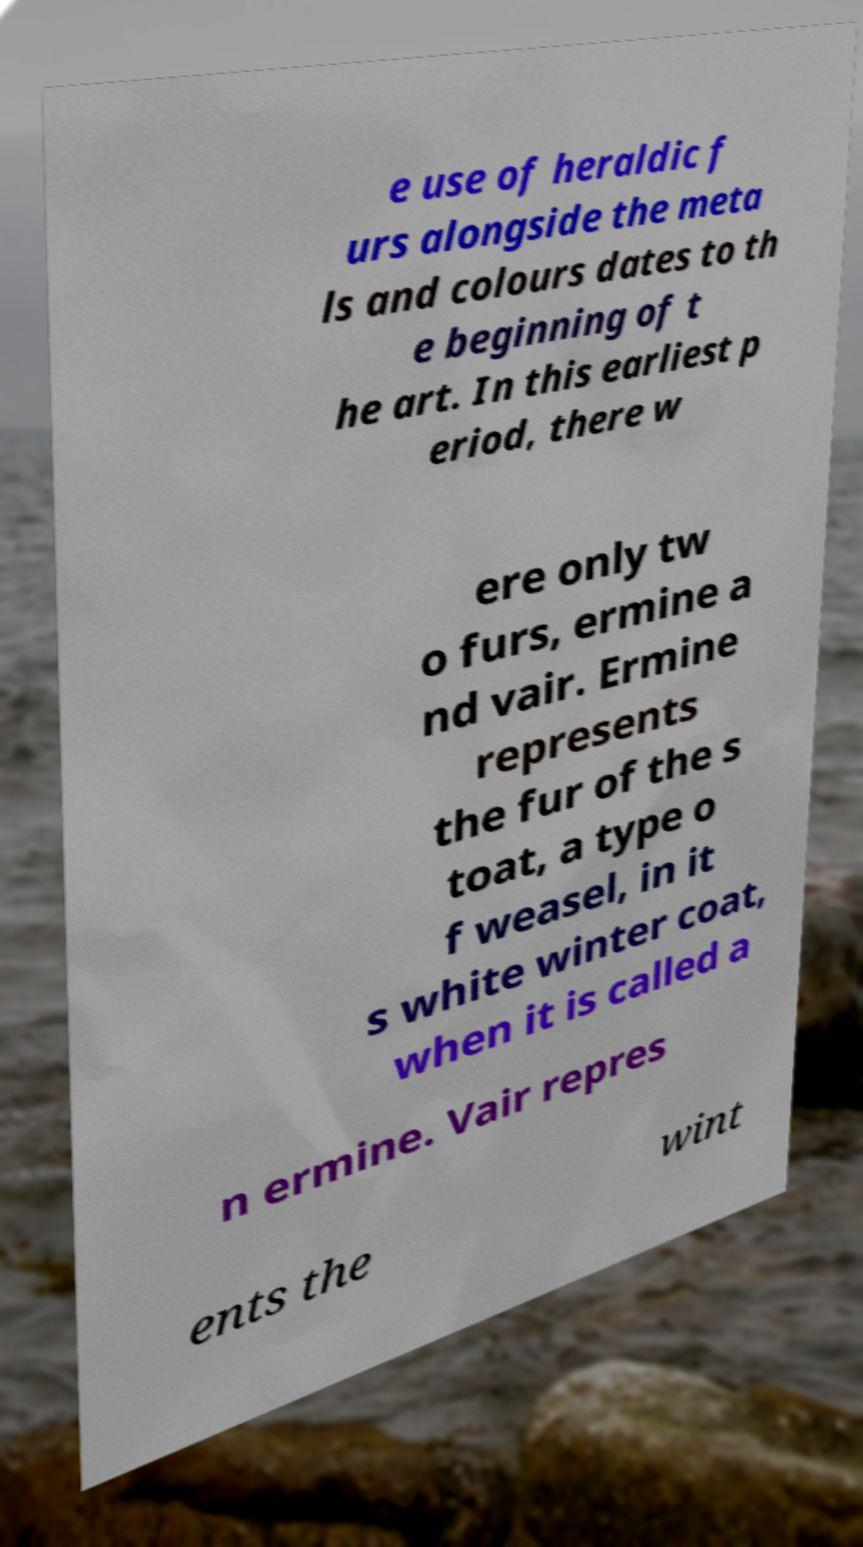Could you extract and type out the text from this image? e use of heraldic f urs alongside the meta ls and colours dates to th e beginning of t he art. In this earliest p eriod, there w ere only tw o furs, ermine a nd vair. Ermine represents the fur of the s toat, a type o f weasel, in it s white winter coat, when it is called a n ermine. Vair repres ents the wint 